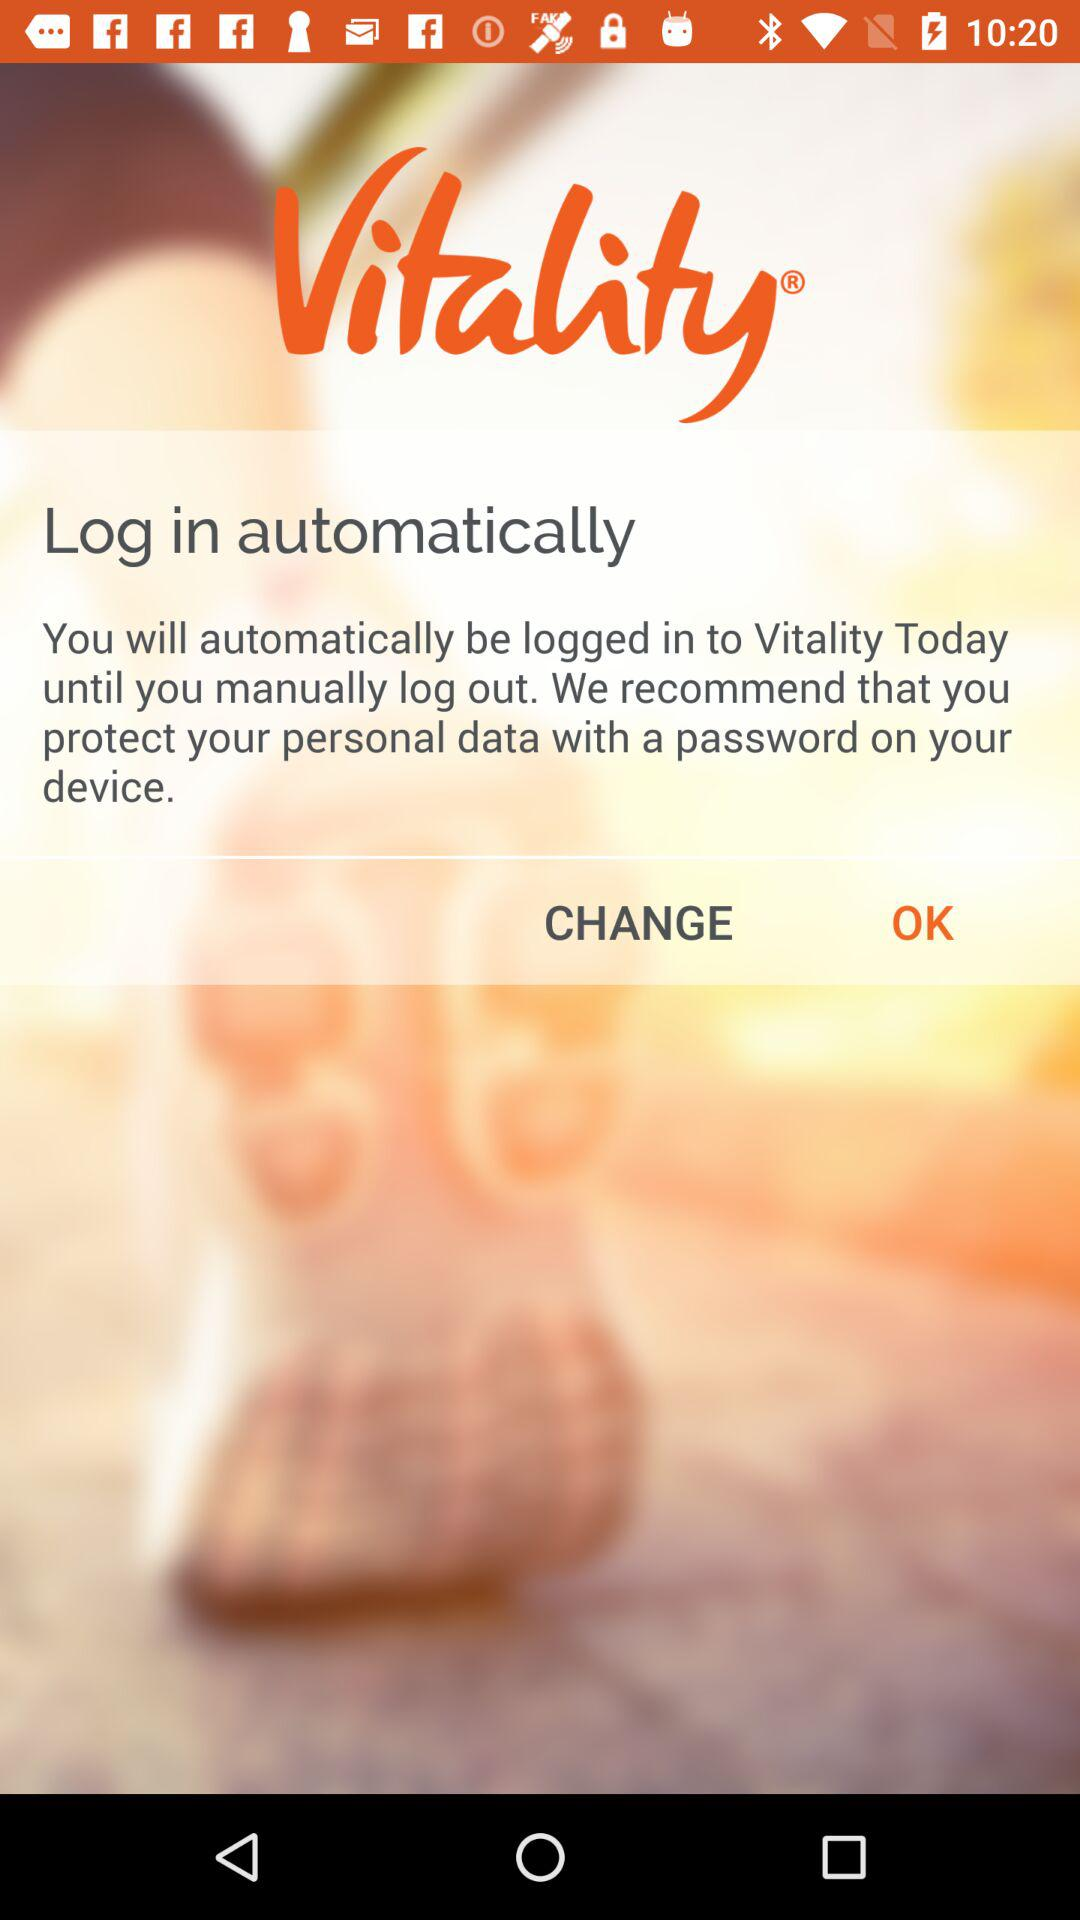What is the name of the application? The name of the application is "Vitality". 